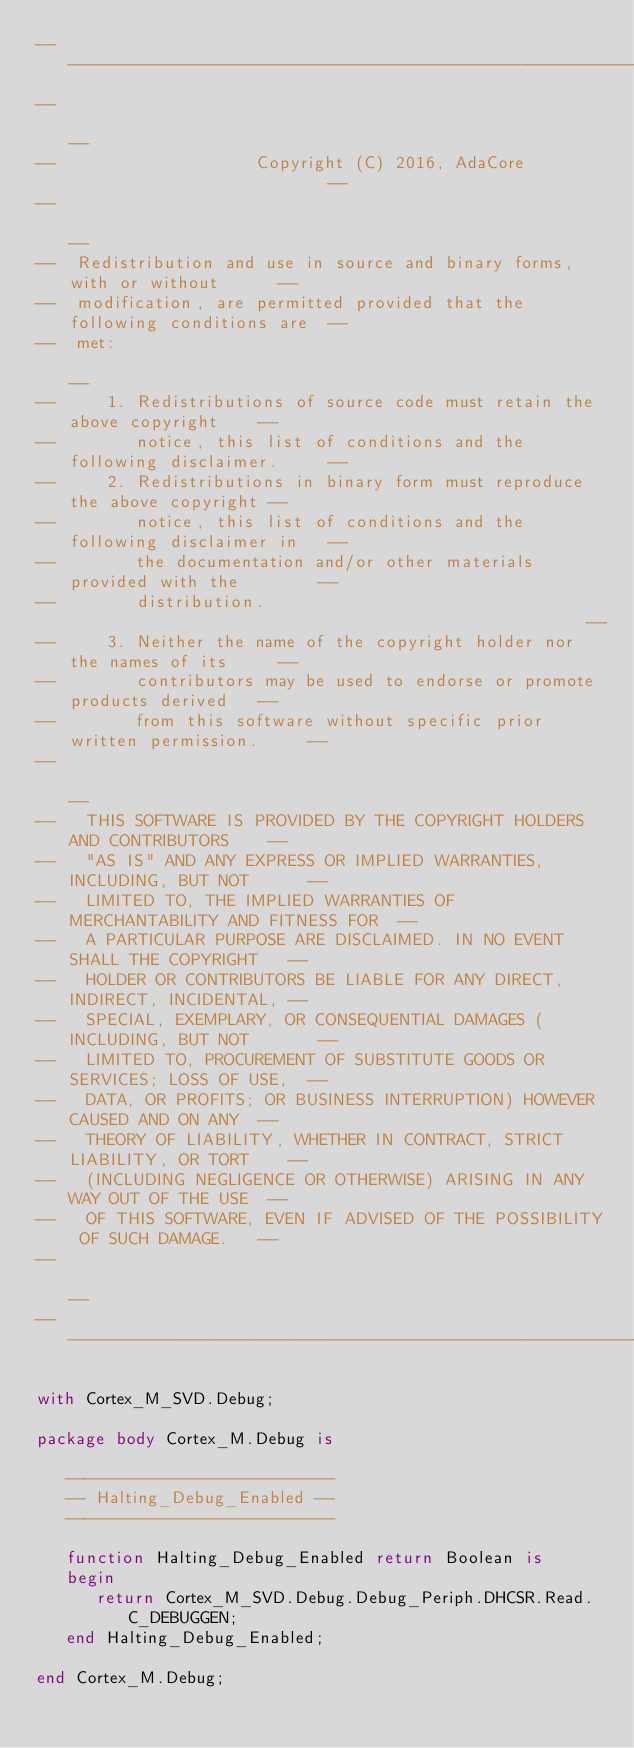Convert code to text. <code><loc_0><loc_0><loc_500><loc_500><_Ada_>------------------------------------------------------------------------------
--                                                                          --
--                    Copyright (C) 2016, AdaCore                           --
--                                                                          --
--  Redistribution and use in source and binary forms, with or without      --
--  modification, are permitted provided that the following conditions are  --
--  met:                                                                    --
--     1. Redistributions of source code must retain the above copyright    --
--        notice, this list of conditions and the following disclaimer.     --
--     2. Redistributions in binary form must reproduce the above copyright --
--        notice, this list of conditions and the following disclaimer in   --
--        the documentation and/or other materials provided with the        --
--        distribution.                                                     --
--     3. Neither the name of the copyright holder nor the names of its     --
--        contributors may be used to endorse or promote products derived   --
--        from this software without specific prior written permission.     --
--                                                                          --
--   THIS SOFTWARE IS PROVIDED BY THE COPYRIGHT HOLDERS AND CONTRIBUTORS    --
--   "AS IS" AND ANY EXPRESS OR IMPLIED WARRANTIES, INCLUDING, BUT NOT      --
--   LIMITED TO, THE IMPLIED WARRANTIES OF MERCHANTABILITY AND FITNESS FOR  --
--   A PARTICULAR PURPOSE ARE DISCLAIMED. IN NO EVENT SHALL THE COPYRIGHT   --
--   HOLDER OR CONTRIBUTORS BE LIABLE FOR ANY DIRECT, INDIRECT, INCIDENTAL, --
--   SPECIAL, EXEMPLARY, OR CONSEQUENTIAL DAMAGES (INCLUDING, BUT NOT       --
--   LIMITED TO, PROCUREMENT OF SUBSTITUTE GOODS OR SERVICES; LOSS OF USE,  --
--   DATA, OR PROFITS; OR BUSINESS INTERRUPTION) HOWEVER CAUSED AND ON ANY  --
--   THEORY OF LIABILITY, WHETHER IN CONTRACT, STRICT LIABILITY, OR TORT    --
--   (INCLUDING NEGLIGENCE OR OTHERWISE) ARISING IN ANY WAY OUT OF THE USE  --
--   OF THIS SOFTWARE, EVEN IF ADVISED OF THE POSSIBILITY OF SUCH DAMAGE.   --
--                                                                          --
------------------------------------------------------------------------------

with Cortex_M_SVD.Debug;

package body Cortex_M.Debug is

   ---------------------------
   -- Halting_Debug_Enabled --
   ---------------------------

   function Halting_Debug_Enabled return Boolean is
   begin
      return Cortex_M_SVD.Debug.Debug_Periph.DHCSR.Read.C_DEBUGGEN;
   end Halting_Debug_Enabled;

end Cortex_M.Debug;
</code> 